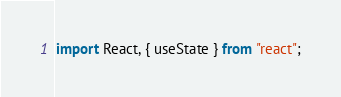Convert code to text. <code><loc_0><loc_0><loc_500><loc_500><_JavaScript_>import React, { useState } from "react";
</code> 